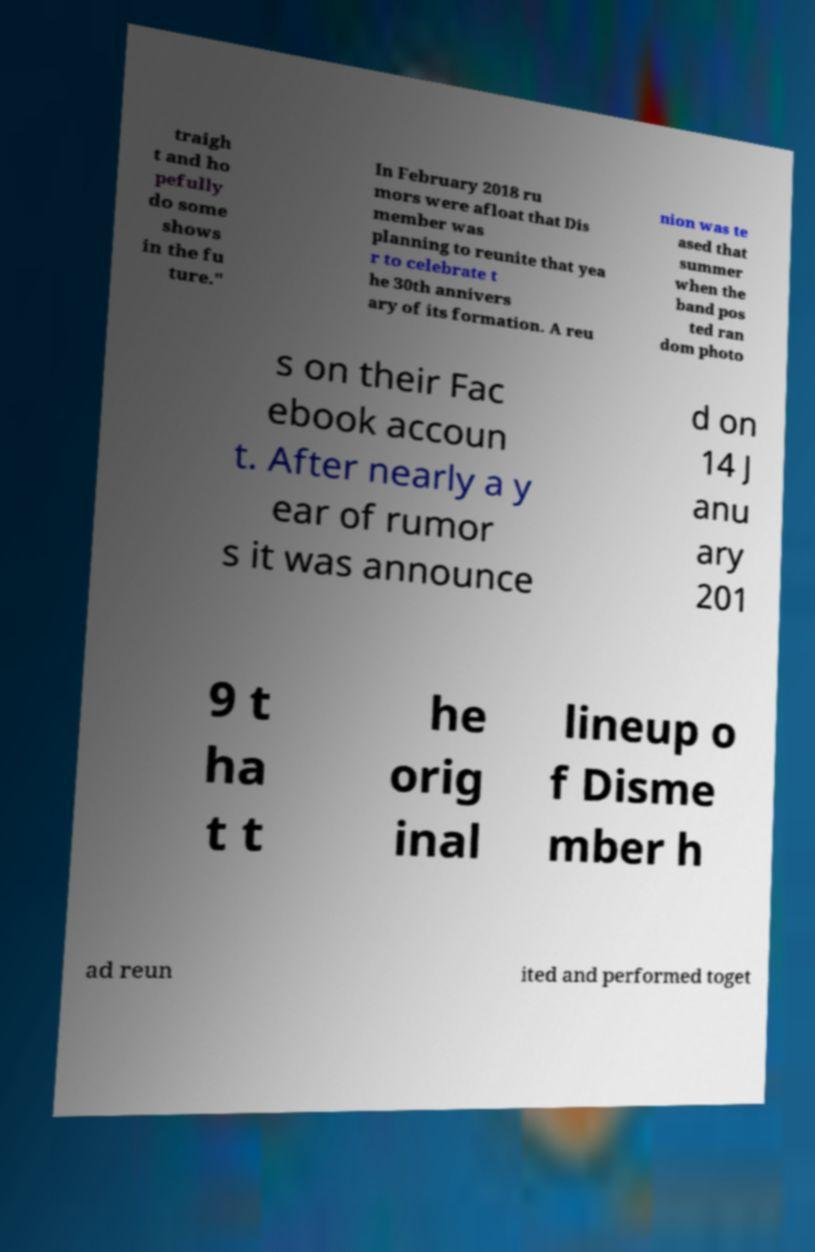What messages or text are displayed in this image? I need them in a readable, typed format. traigh t and ho pefully do some shows in the fu ture." In February 2018 ru mors were afloat that Dis member was planning to reunite that yea r to celebrate t he 30th annivers ary of its formation. A reu nion was te ased that summer when the band pos ted ran dom photo s on their Fac ebook accoun t. After nearly a y ear of rumor s it was announce d on 14 J anu ary 201 9 t ha t t he orig inal lineup o f Disme mber h ad reun ited and performed toget 